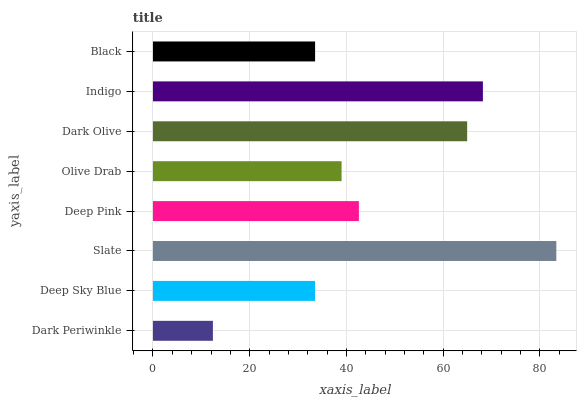Is Dark Periwinkle the minimum?
Answer yes or no. Yes. Is Slate the maximum?
Answer yes or no. Yes. Is Deep Sky Blue the minimum?
Answer yes or no. No. Is Deep Sky Blue the maximum?
Answer yes or no. No. Is Deep Sky Blue greater than Dark Periwinkle?
Answer yes or no. Yes. Is Dark Periwinkle less than Deep Sky Blue?
Answer yes or no. Yes. Is Dark Periwinkle greater than Deep Sky Blue?
Answer yes or no. No. Is Deep Sky Blue less than Dark Periwinkle?
Answer yes or no. No. Is Deep Pink the high median?
Answer yes or no. Yes. Is Olive Drab the low median?
Answer yes or no. Yes. Is Slate the high median?
Answer yes or no. No. Is Slate the low median?
Answer yes or no. No. 